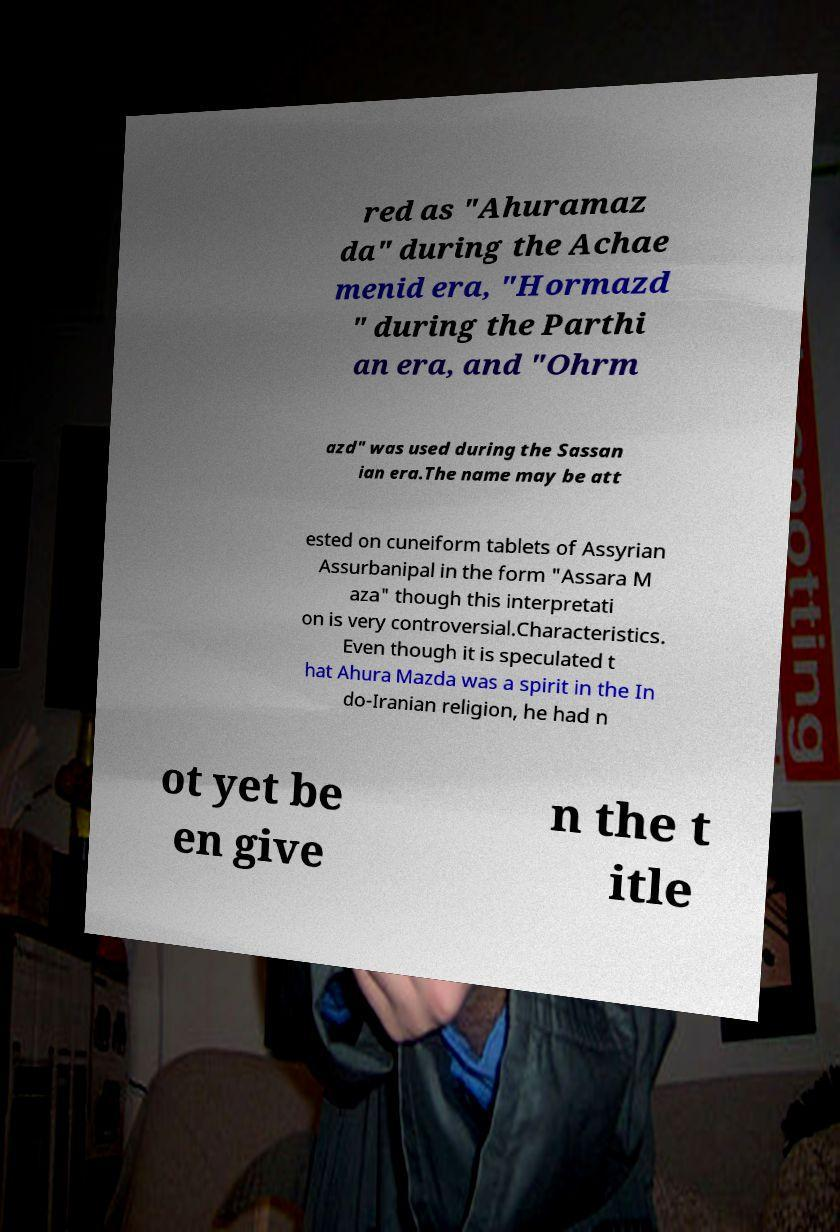Can you accurately transcribe the text from the provided image for me? red as "Ahuramaz da" during the Achae menid era, "Hormazd " during the Parthi an era, and "Ohrm azd" was used during the Sassan ian era.The name may be att ested on cuneiform tablets of Assyrian Assurbanipal in the form "Assara M aza" though this interpretati on is very controversial.Characteristics. Even though it is speculated t hat Ahura Mazda was a spirit in the In do-Iranian religion, he had n ot yet be en give n the t itle 